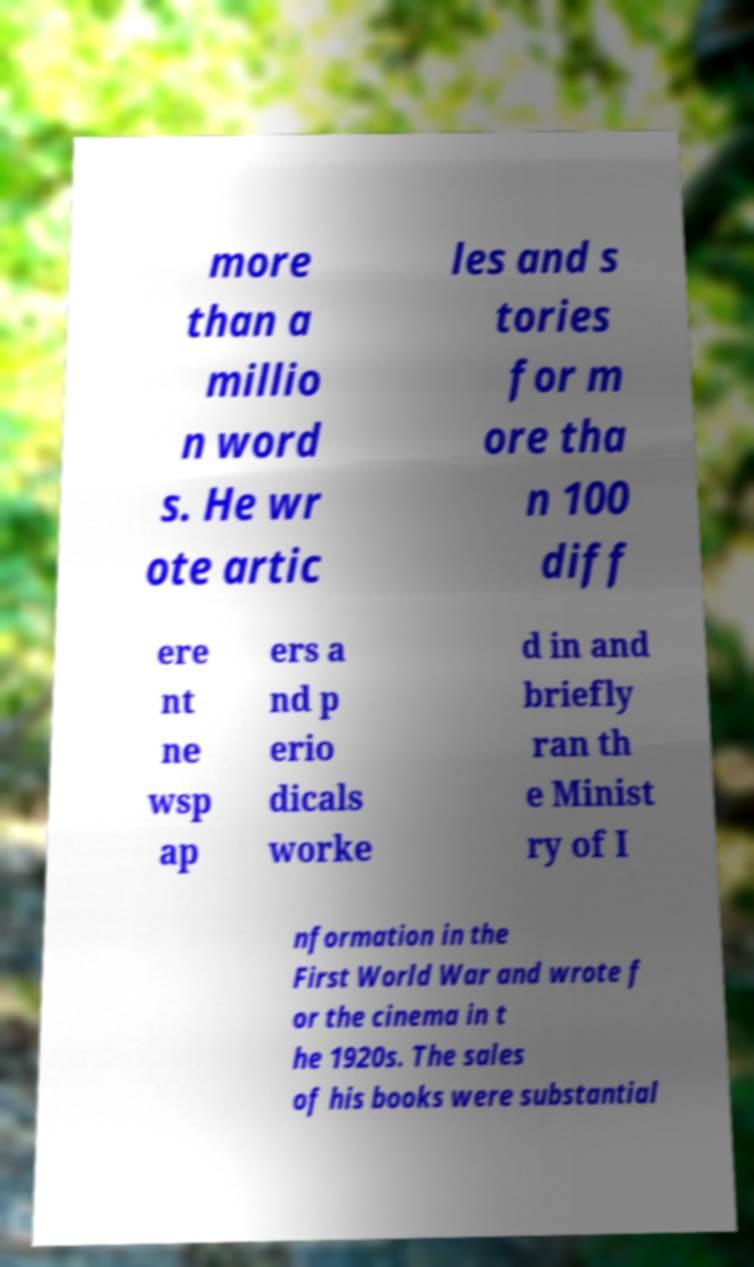Could you assist in decoding the text presented in this image and type it out clearly? more than a millio n word s. He wr ote artic les and s tories for m ore tha n 100 diff ere nt ne wsp ap ers a nd p erio dicals worke d in and briefly ran th e Minist ry of I nformation in the First World War and wrote f or the cinema in t he 1920s. The sales of his books were substantial 